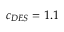Convert formula to latex. <formula><loc_0><loc_0><loc_500><loc_500>c _ { D E S } = 1 . 1</formula> 